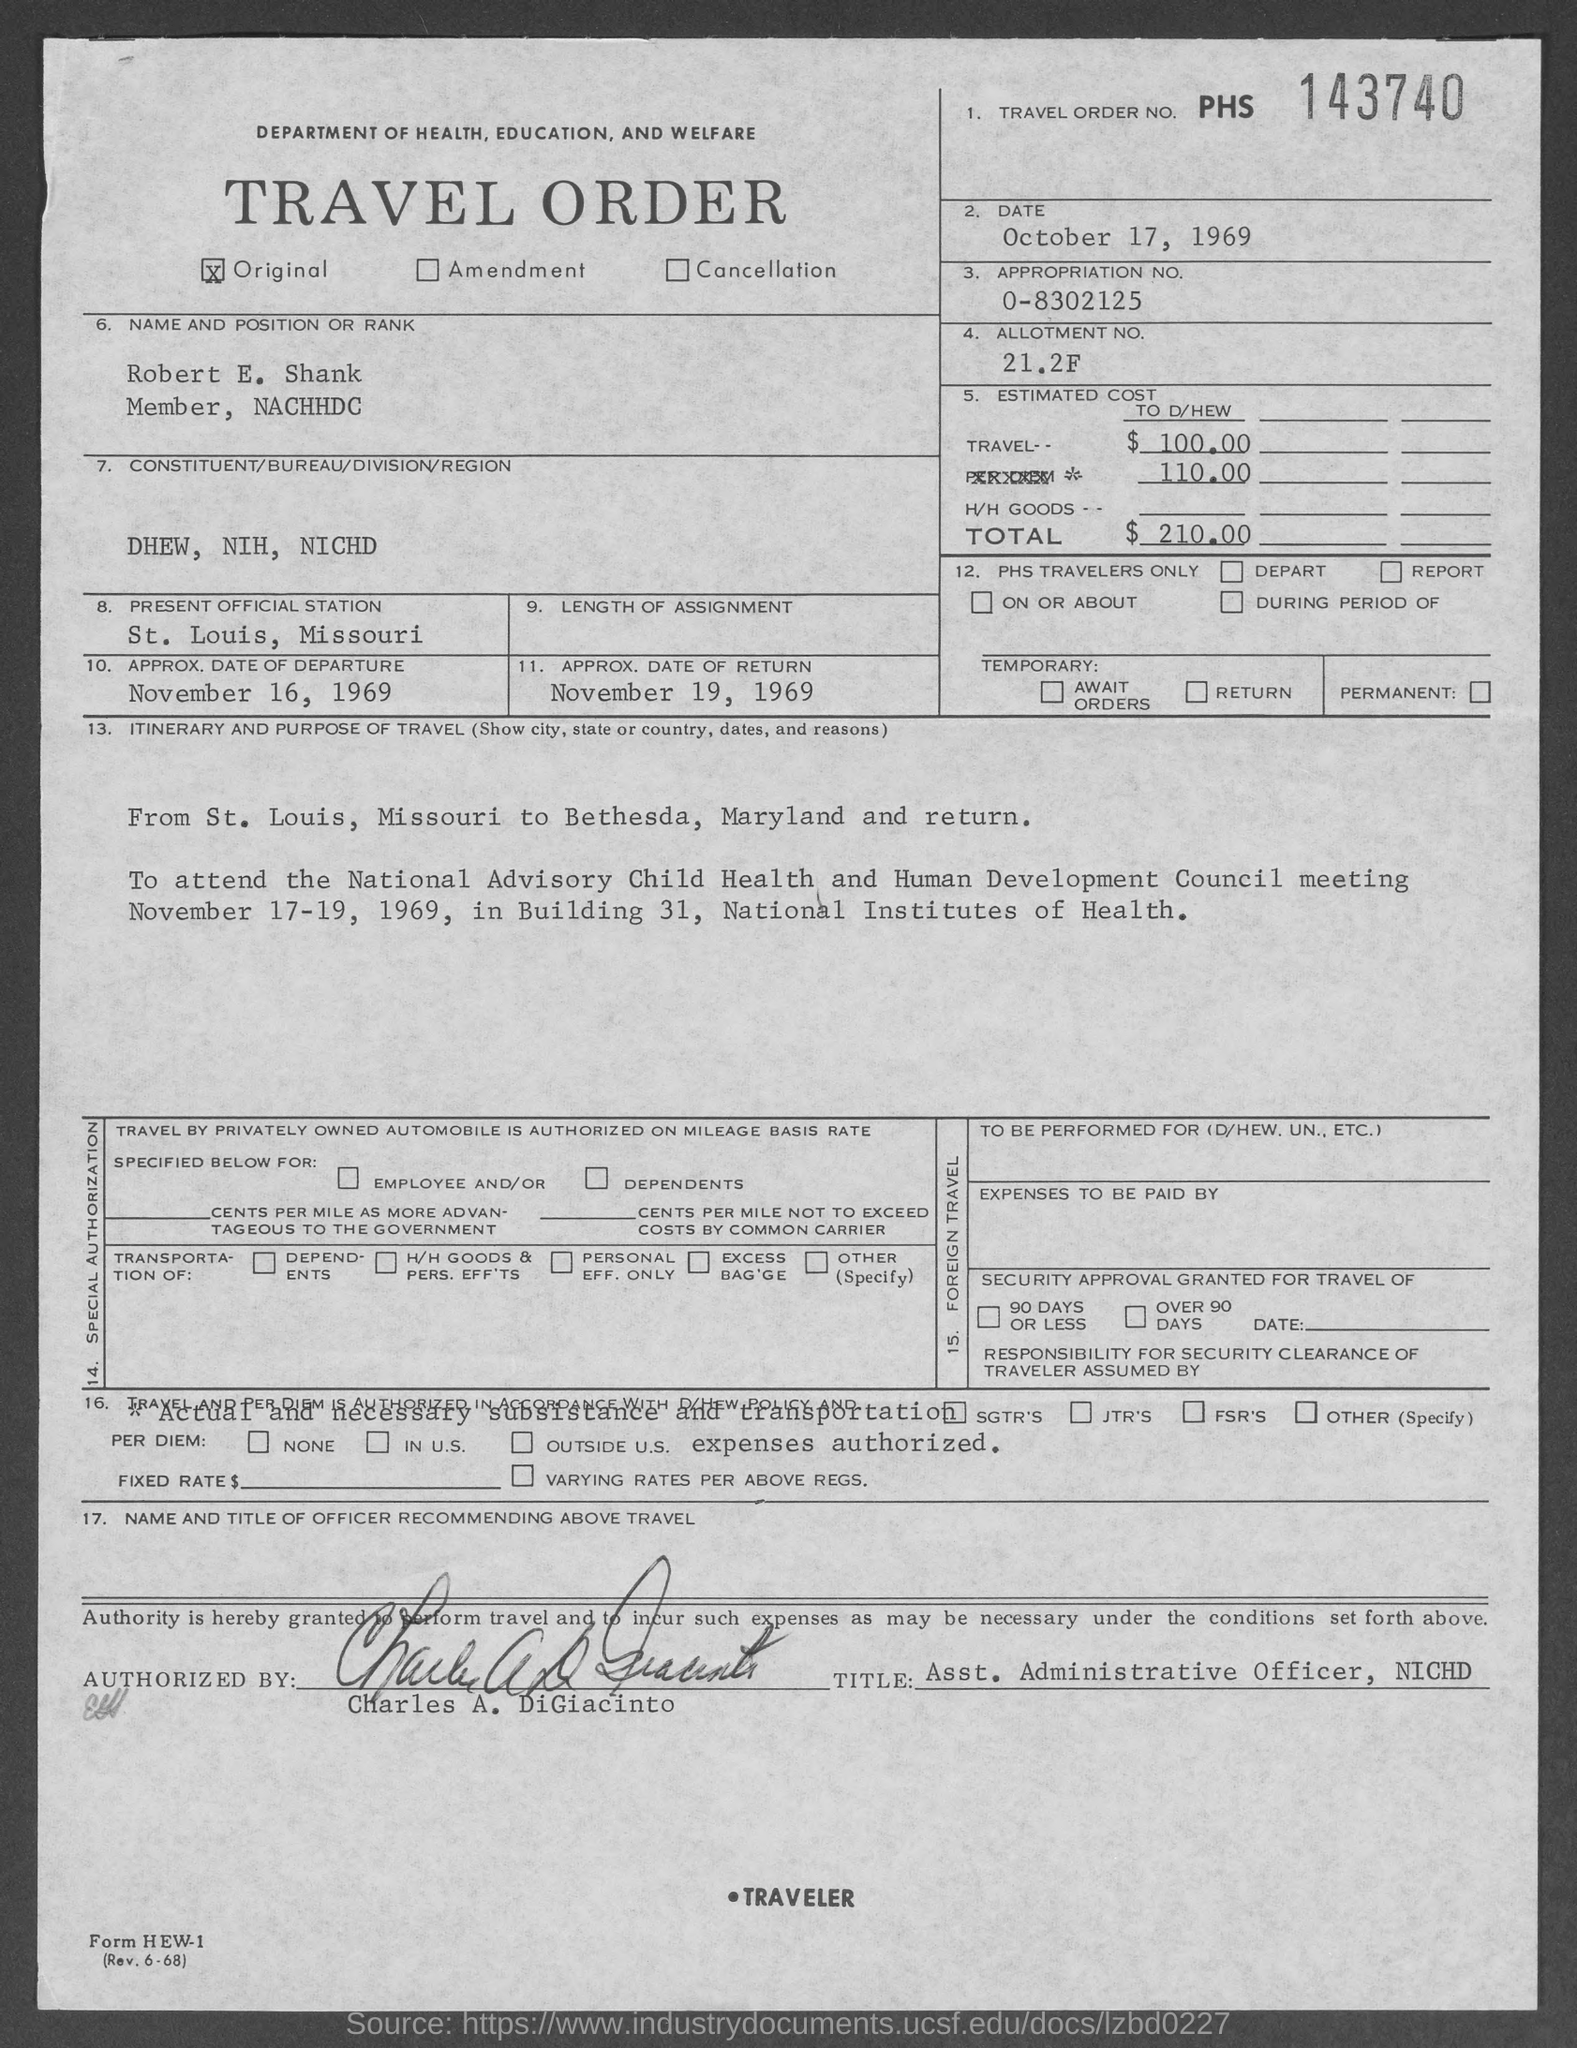Identify some key points in this picture. The travel order number mentioned in the given form is PHS 143740. The approximate date of return mentioned in the given form is November 19, 1969. The appropriation number mentioned in the provided form is 0-8302125. What is the allotment number mentioned in the given form? 21.2F.. The departure date mentioned in the given form is approximately November 16, 1969. 